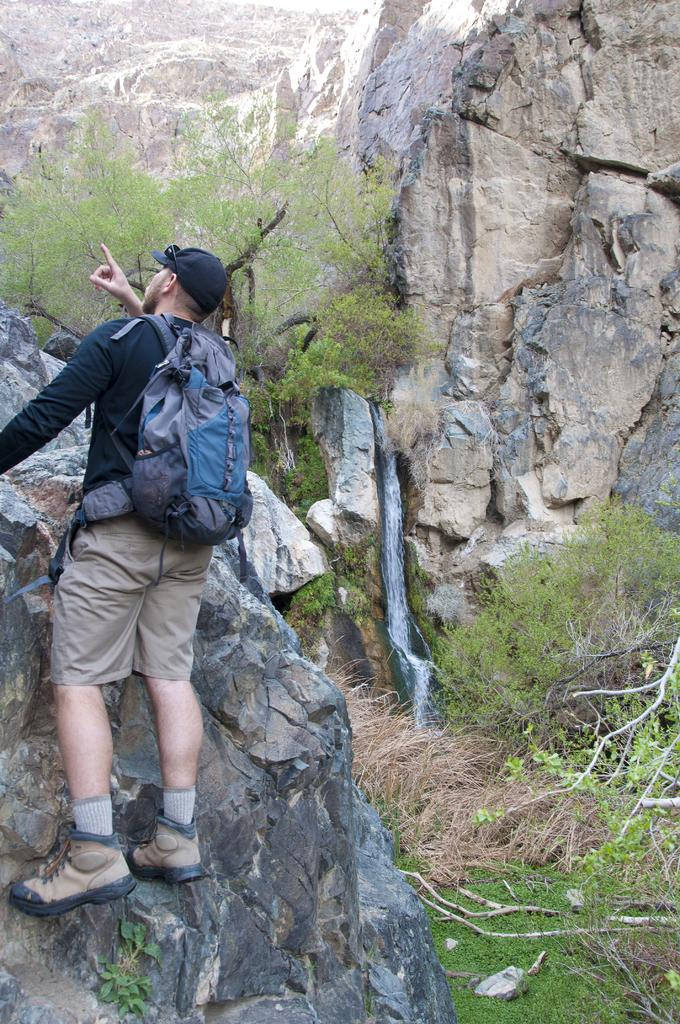Who is in the image? There is a person in the image. What is the person wearing? The person is wearing a backpack. What activity is the person engaged in? The person is climbing a rock. What type of vegetation can be seen in the image? Trees and plants are visible in the image. What type of shoe is the person wearing while climbing the rock? The provided facts do not mention any shoes, so we cannot determine the type of shoe the person is wearing. 